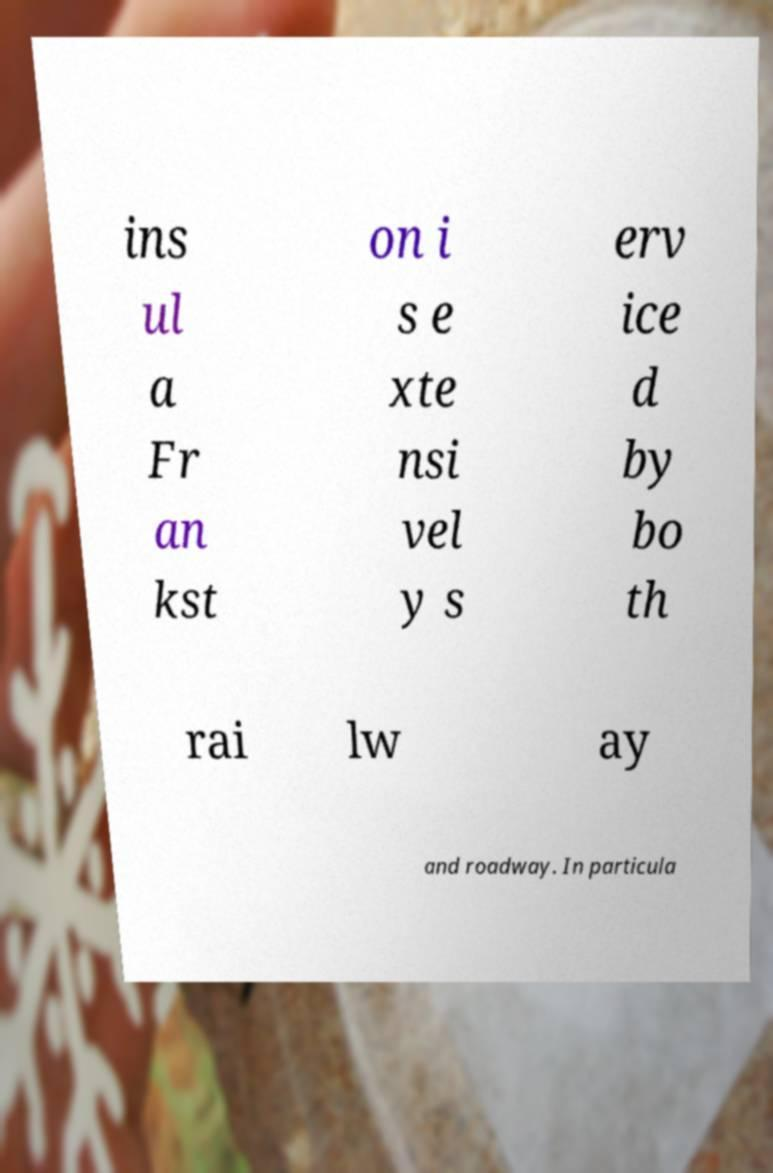I need the written content from this picture converted into text. Can you do that? ins ul a Fr an kst on i s e xte nsi vel y s erv ice d by bo th rai lw ay and roadway. In particula 